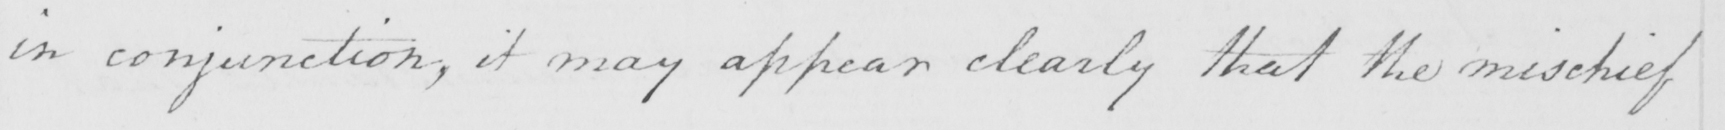Can you read and transcribe this handwriting? in conjunction , it may appear clearly that the mischief 